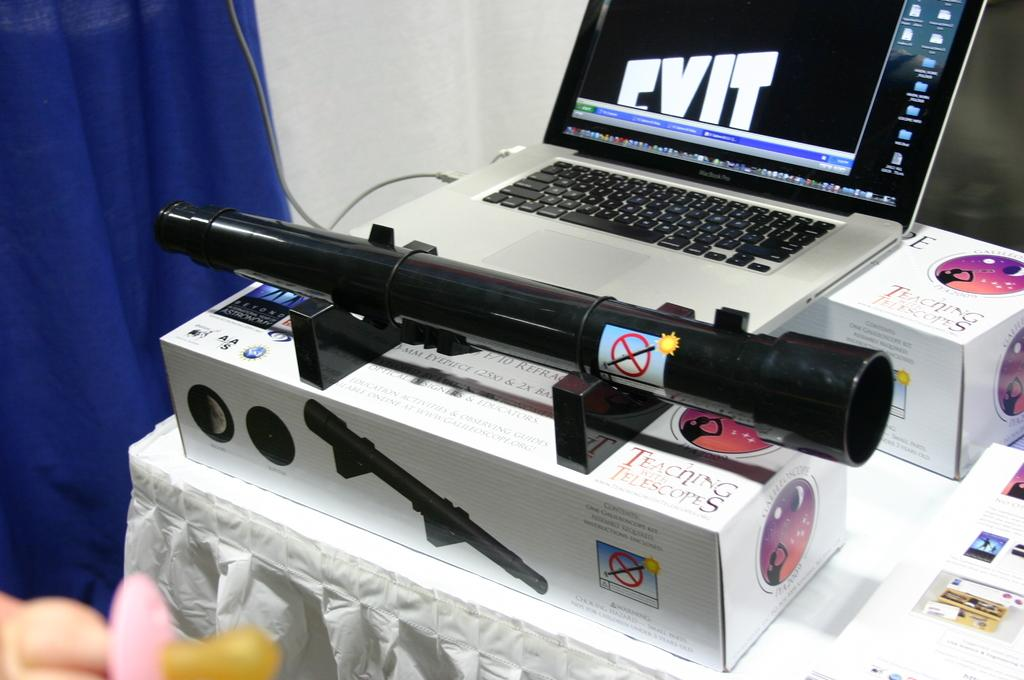Provide a one-sentence caption for the provided image. A couple of oblong boxes have Teaching with Telescopes written on them. 